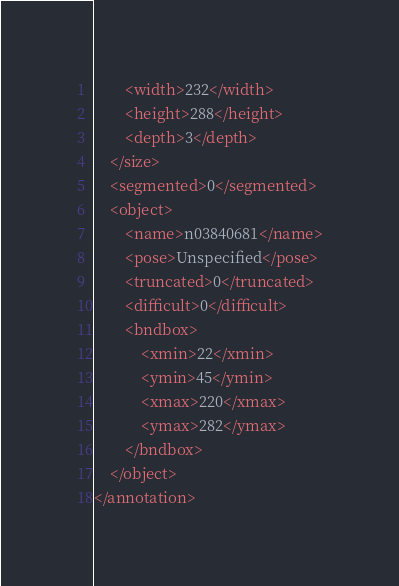<code> <loc_0><loc_0><loc_500><loc_500><_XML_>		<width>232</width>
		<height>288</height>
		<depth>3</depth>
	</size>
	<segmented>0</segmented>
	<object>
		<name>n03840681</name>
		<pose>Unspecified</pose>
		<truncated>0</truncated>
		<difficult>0</difficult>
		<bndbox>
			<xmin>22</xmin>
			<ymin>45</ymin>
			<xmax>220</xmax>
			<ymax>282</ymax>
		</bndbox>
	</object>
</annotation></code> 